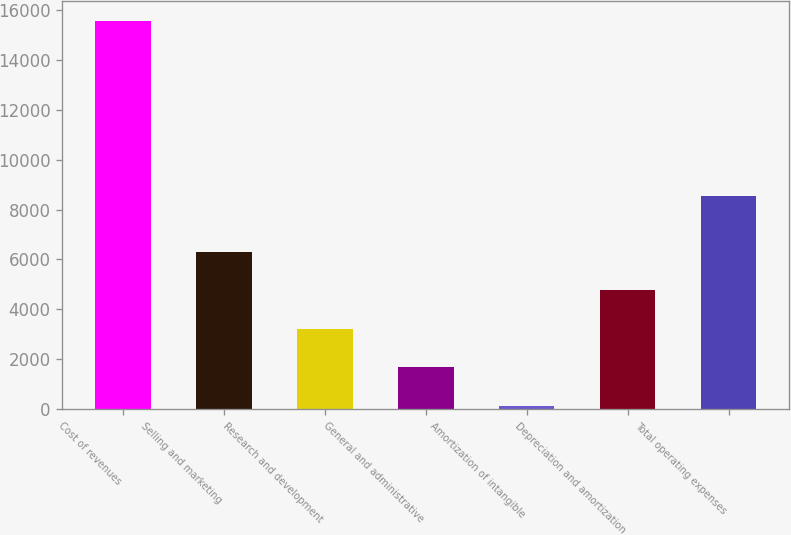<chart> <loc_0><loc_0><loc_500><loc_500><bar_chart><fcel>Cost of revenues<fcel>Selling and marketing<fcel>Research and development<fcel>General and administrative<fcel>Amortization of intangible<fcel>Depreciation and amortization<fcel>Total operating expenses<nl><fcel>15588<fcel>6309<fcel>3216<fcel>1669.5<fcel>123<fcel>4762.5<fcel>8550<nl></chart> 